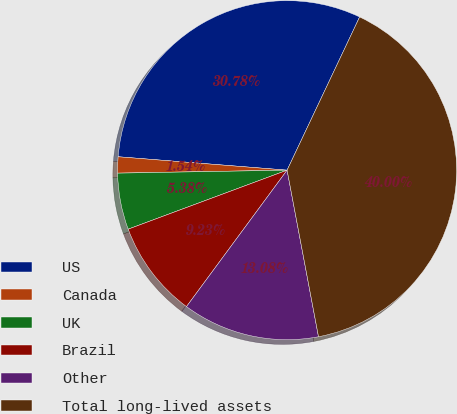Convert chart. <chart><loc_0><loc_0><loc_500><loc_500><pie_chart><fcel>US<fcel>Canada<fcel>UK<fcel>Brazil<fcel>Other<fcel>Total long-lived assets<nl><fcel>30.78%<fcel>1.54%<fcel>5.38%<fcel>9.23%<fcel>13.08%<fcel>40.0%<nl></chart> 